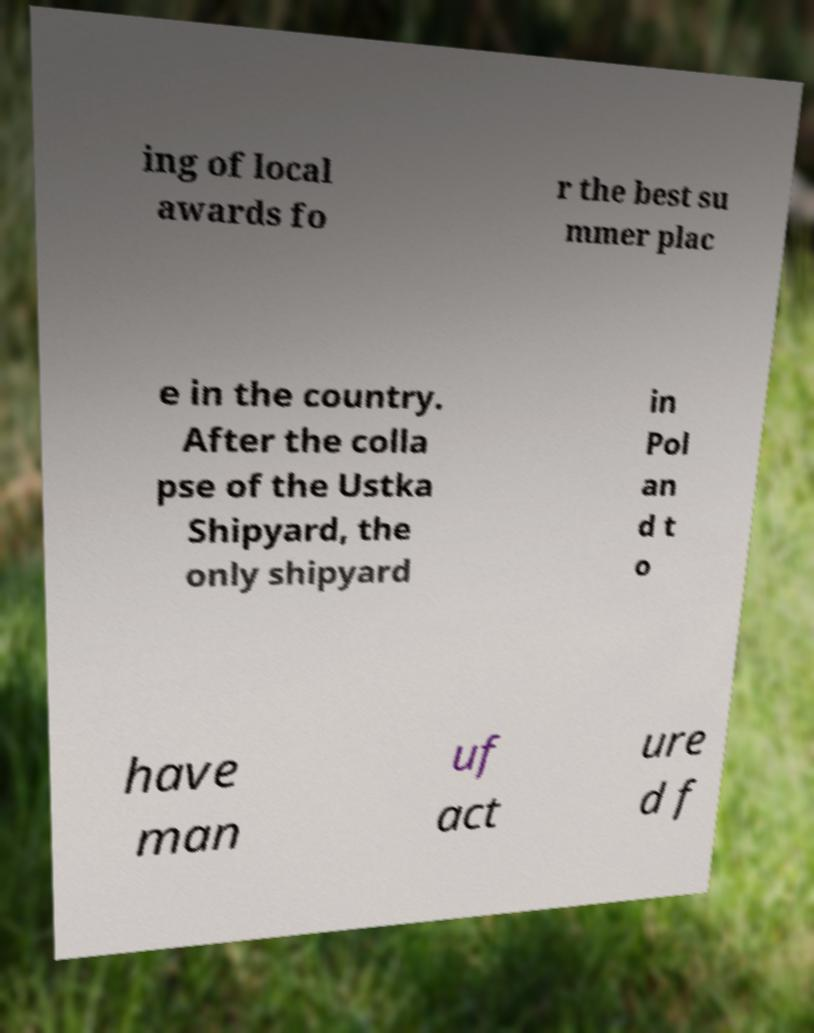Please read and relay the text visible in this image. What does it say? ing of local awards fo r the best su mmer plac e in the country. After the colla pse of the Ustka Shipyard, the only shipyard in Pol an d t o have man uf act ure d f 